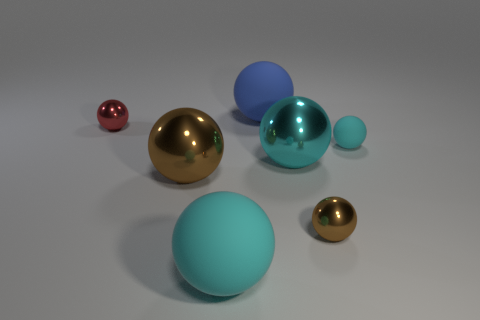Are there fewer cyan matte balls than small brown metal balls?
Provide a succinct answer. No. How many things are either tiny red metallic balls or big metallic objects?
Offer a very short reply. 3. Is the large blue thing the same shape as the tiny matte object?
Offer a very short reply. Yes. Is there any other thing that has the same material as the big blue ball?
Your answer should be very brief. Yes. There is a cyan object on the left side of the large blue rubber sphere; is it the same size as the cyan ball right of the large cyan metal object?
Provide a short and direct response. No. What material is the big sphere that is both behind the small brown metal object and to the left of the blue rubber object?
Offer a terse response. Metal. Is there anything else that has the same color as the small matte sphere?
Give a very brief answer. Yes. Are there fewer cyan rubber objects behind the big cyan metal sphere than small red matte objects?
Offer a very short reply. No. Is the number of tiny objects greater than the number of tiny green matte cylinders?
Give a very brief answer. Yes. Are there any big matte balls to the left of the big cyan object in front of the brown object behind the tiny brown sphere?
Ensure brevity in your answer.  No. 